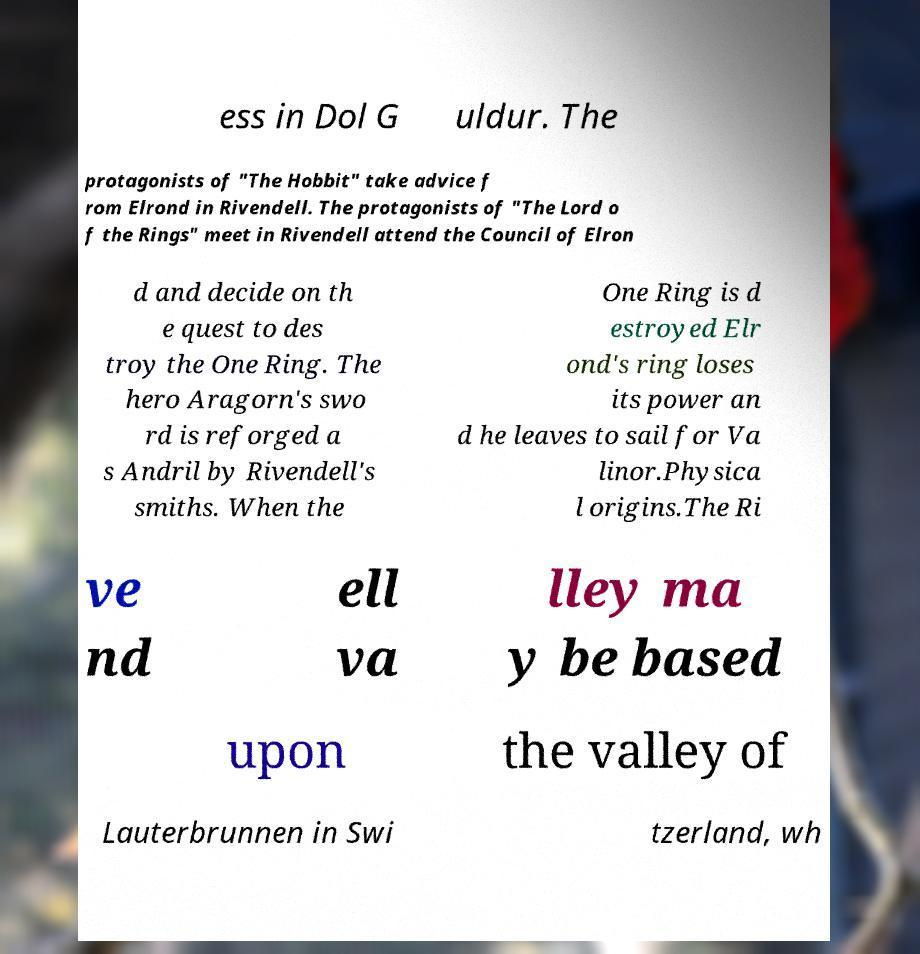For documentation purposes, I need the text within this image transcribed. Could you provide that? ess in Dol G uldur. The protagonists of "The Hobbit" take advice f rom Elrond in Rivendell. The protagonists of "The Lord o f the Rings" meet in Rivendell attend the Council of Elron d and decide on th e quest to des troy the One Ring. The hero Aragorn's swo rd is reforged a s Andril by Rivendell's smiths. When the One Ring is d estroyed Elr ond's ring loses its power an d he leaves to sail for Va linor.Physica l origins.The Ri ve nd ell va lley ma y be based upon the valley of Lauterbrunnen in Swi tzerland, wh 